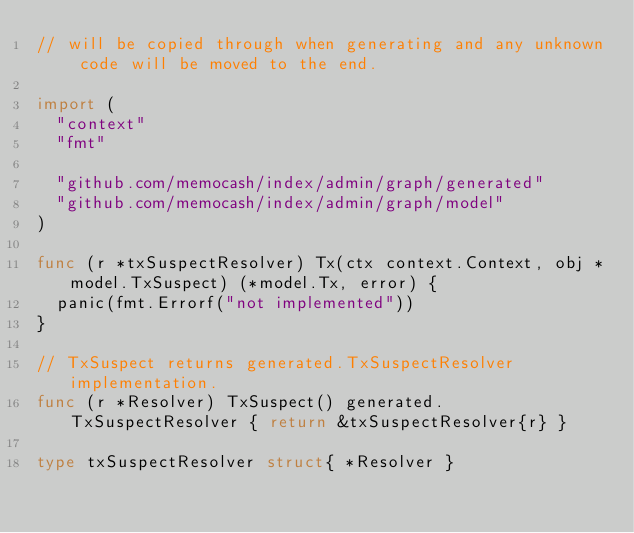<code> <loc_0><loc_0><loc_500><loc_500><_Go_>// will be copied through when generating and any unknown code will be moved to the end.

import (
	"context"
	"fmt"

	"github.com/memocash/index/admin/graph/generated"
	"github.com/memocash/index/admin/graph/model"
)

func (r *txSuspectResolver) Tx(ctx context.Context, obj *model.TxSuspect) (*model.Tx, error) {
	panic(fmt.Errorf("not implemented"))
}

// TxSuspect returns generated.TxSuspectResolver implementation.
func (r *Resolver) TxSuspect() generated.TxSuspectResolver { return &txSuspectResolver{r} }

type txSuspectResolver struct{ *Resolver }
</code> 